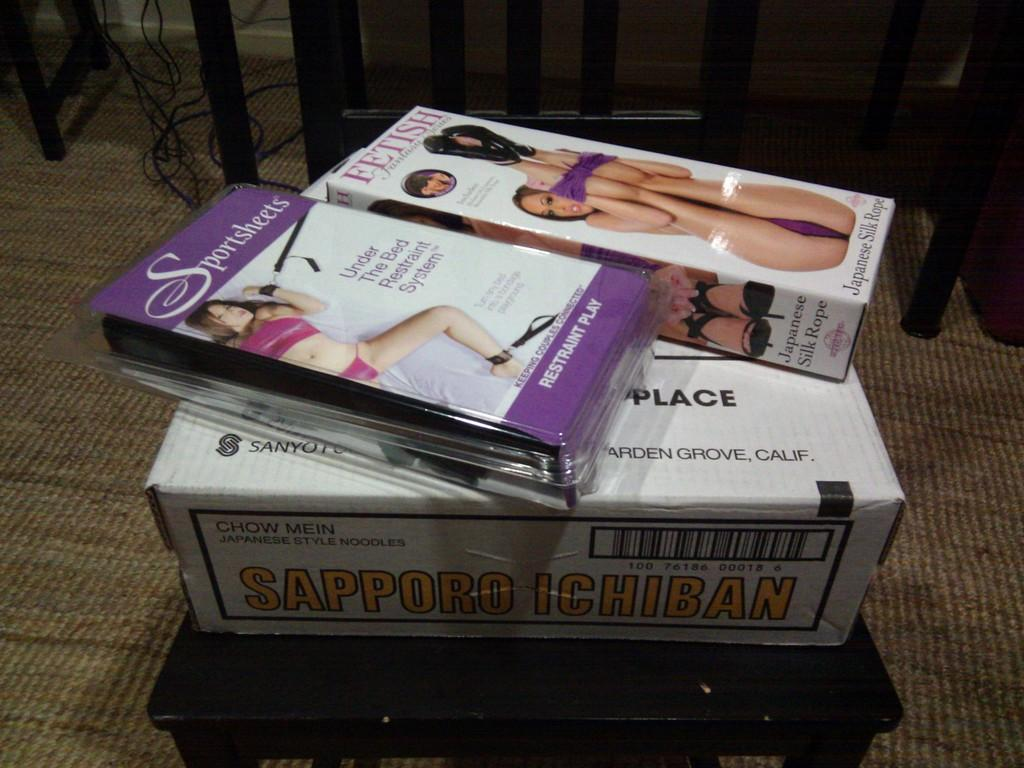<image>
Write a terse but informative summary of the picture. Two packages of fetish and a restraint system on top of a parcel box. 